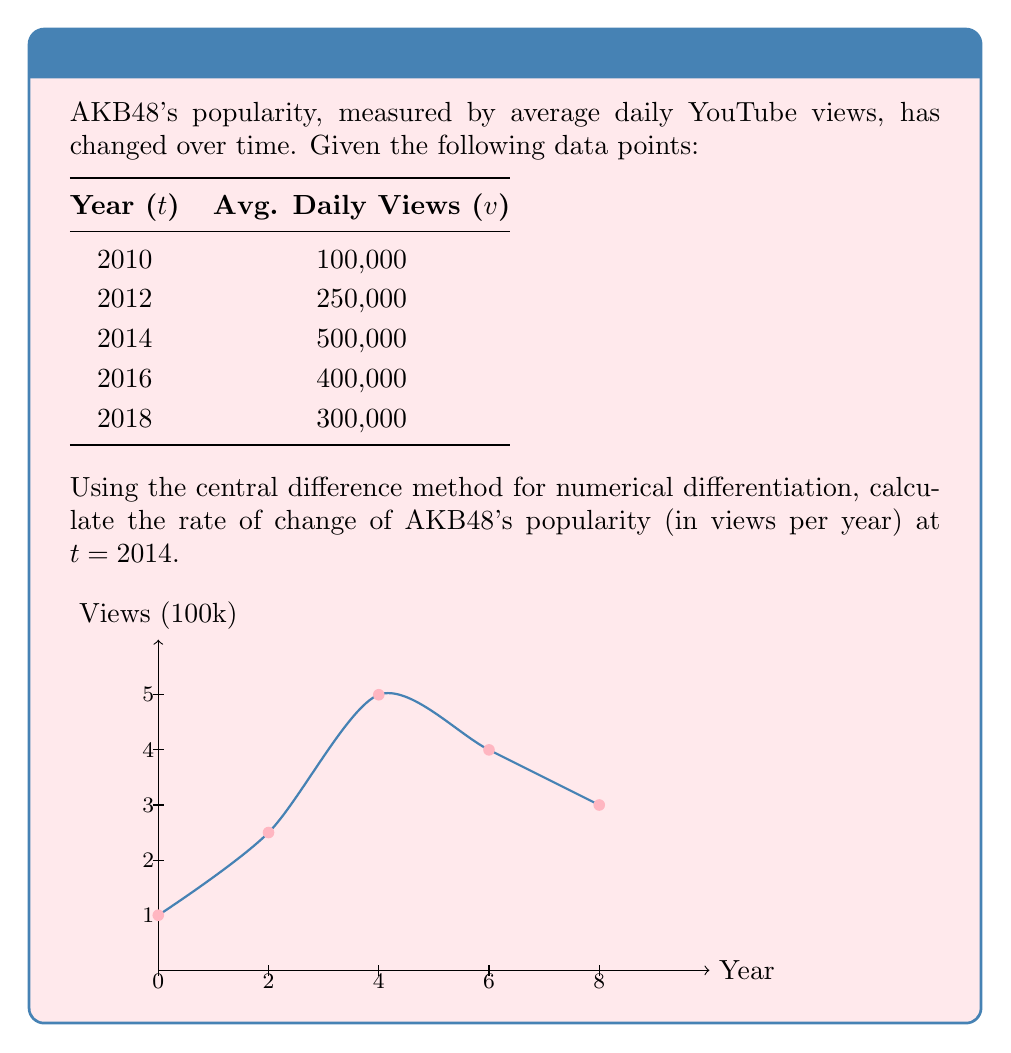Can you answer this question? To solve this problem, we'll use the central difference method for numerical differentiation. The formula for the central difference approximation of the first derivative is:

$$ f'(x) \approx \frac{f(x+h) - f(x-h)}{2h} $$

Where $h$ is the step size.

Step 1: Identify the relevant data points
For t = 2014, we need the data points before and after:
t = 2012, v = 250,000
t = 2014, v = 500,000
t = 2016, v = 400,000

Step 2: Determine the step size (h)
h = 2 years

Step 3: Apply the central difference formula
$$ v'(2014) \approx \frac{v(2016) - v(2012)}{2h} $$

$$ v'(2014) \approx \frac{400,000 - 250,000}{2(2)} $$

$$ v'(2014) \approx \frac{150,000}{4} $$

$$ v'(2014) \approx 37,500 $$

Step 4: Interpret the result
The rate of change at t = 2014 is approximately 37,500 views per year.
Answer: 37,500 views/year 